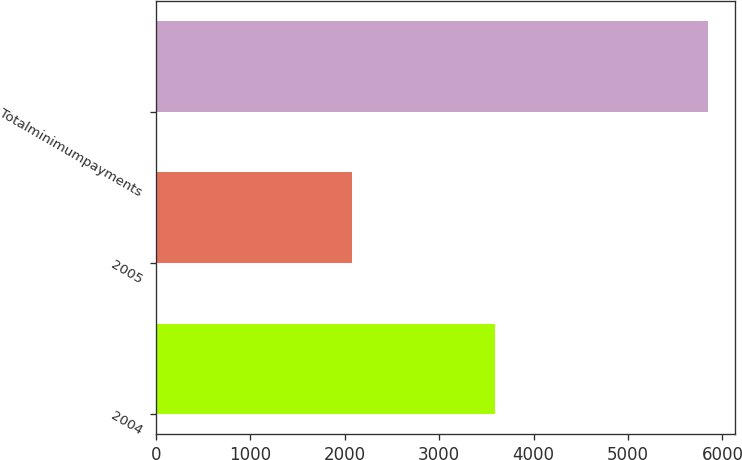Convert chart. <chart><loc_0><loc_0><loc_500><loc_500><bar_chart><fcel>2004<fcel>2005<fcel>Totalminimumpayments<nl><fcel>3592<fcel>2076<fcel>5843<nl></chart> 